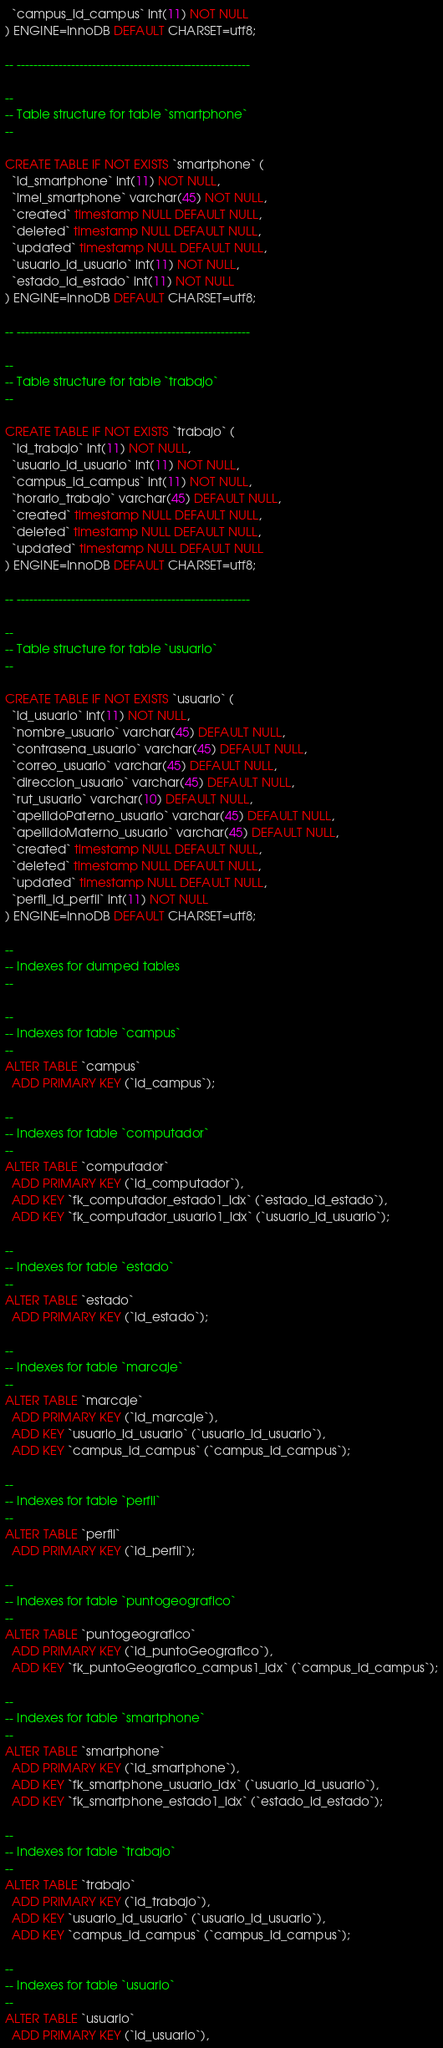<code> <loc_0><loc_0><loc_500><loc_500><_SQL_>  `campus_id_campus` int(11) NOT NULL
) ENGINE=InnoDB DEFAULT CHARSET=utf8;

-- --------------------------------------------------------

--
-- Table structure for table `smartphone`
--

CREATE TABLE IF NOT EXISTS `smartphone` (
  `id_smartphone` int(11) NOT NULL,
  `imei_smartphone` varchar(45) NOT NULL,
  `created` timestamp NULL DEFAULT NULL,
  `deleted` timestamp NULL DEFAULT NULL,
  `updated` timestamp NULL DEFAULT NULL,
  `usuario_id_usuario` int(11) NOT NULL,
  `estado_id_estado` int(11) NOT NULL
) ENGINE=InnoDB DEFAULT CHARSET=utf8;

-- --------------------------------------------------------

--
-- Table structure for table `trabajo`
--

CREATE TABLE IF NOT EXISTS `trabajo` (
  `id_trabajo` int(11) NOT NULL,
  `usuario_id_usuario` int(11) NOT NULL,
  `campus_id_campus` int(11) NOT NULL,
  `horario_trabajo` varchar(45) DEFAULT NULL,
  `created` timestamp NULL DEFAULT NULL,
  `deleted` timestamp NULL DEFAULT NULL,
  `updated` timestamp NULL DEFAULT NULL
) ENGINE=InnoDB DEFAULT CHARSET=utf8;

-- --------------------------------------------------------

--
-- Table structure for table `usuario`
--

CREATE TABLE IF NOT EXISTS `usuario` (
  `id_usuario` int(11) NOT NULL,
  `nombre_usuario` varchar(45) DEFAULT NULL,
  `contrasena_usuario` varchar(45) DEFAULT NULL,
  `correo_usuario` varchar(45) DEFAULT NULL,
  `direccion_usuario` varchar(45) DEFAULT NULL,
  `rut_usuario` varchar(10) DEFAULT NULL,
  `apellidoPaterno_usuario` varchar(45) DEFAULT NULL,
  `apellidoMaterno_usuario` varchar(45) DEFAULT NULL,
  `created` timestamp NULL DEFAULT NULL,
  `deleted` timestamp NULL DEFAULT NULL,
  `updated` timestamp NULL DEFAULT NULL,
  `perfil_id_perfil` int(11) NOT NULL
) ENGINE=InnoDB DEFAULT CHARSET=utf8;

--
-- Indexes for dumped tables
--

--
-- Indexes for table `campus`
--
ALTER TABLE `campus`
  ADD PRIMARY KEY (`id_campus`);

--
-- Indexes for table `computador`
--
ALTER TABLE `computador`
  ADD PRIMARY KEY (`id_computador`),
  ADD KEY `fk_computador_estado1_idx` (`estado_id_estado`),
  ADD KEY `fk_computador_usuario1_idx` (`usuario_id_usuario`);

--
-- Indexes for table `estado`
--
ALTER TABLE `estado`
  ADD PRIMARY KEY (`id_estado`);

--
-- Indexes for table `marcaje`
--
ALTER TABLE `marcaje`
  ADD PRIMARY KEY (`id_marcaje`),
  ADD KEY `usuario_id_usuario` (`usuario_id_usuario`),
  ADD KEY `campus_id_campus` (`campus_id_campus`);

--
-- Indexes for table `perfil`
--
ALTER TABLE `perfil`
  ADD PRIMARY KEY (`id_perfil`);

--
-- Indexes for table `puntogeografico`
--
ALTER TABLE `puntogeografico`
  ADD PRIMARY KEY (`id_puntoGeografico`),
  ADD KEY `fk_puntoGeografico_campus1_idx` (`campus_id_campus`);

--
-- Indexes for table `smartphone`
--
ALTER TABLE `smartphone`
  ADD PRIMARY KEY (`id_smartphone`),
  ADD KEY `fk_smartphone_usuario_idx` (`usuario_id_usuario`),
  ADD KEY `fk_smartphone_estado1_idx` (`estado_id_estado`);

--
-- Indexes for table `trabajo`
--
ALTER TABLE `trabajo`
  ADD PRIMARY KEY (`id_trabajo`),
  ADD KEY `usuario_id_usuario` (`usuario_id_usuario`),
  ADD KEY `campus_id_campus` (`campus_id_campus`);

--
-- Indexes for table `usuario`
--
ALTER TABLE `usuario`
  ADD PRIMARY KEY (`id_usuario`),</code> 